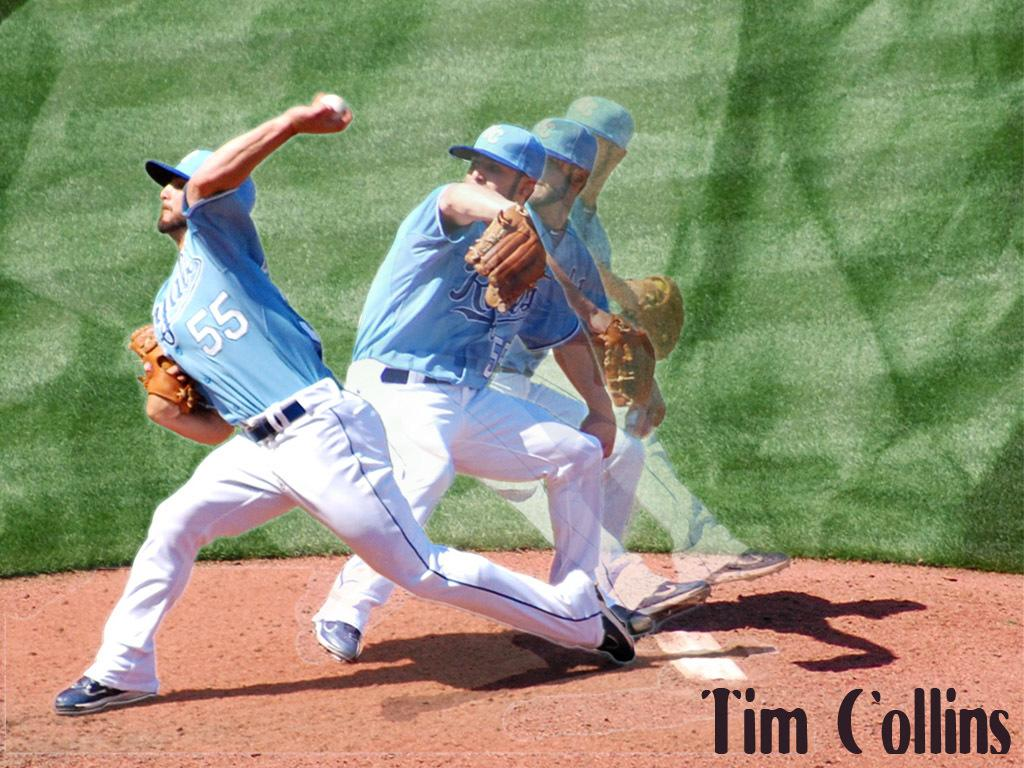<image>
Render a clear and concise summary of the photo. A baseball pitcher for the Royals is throwing a ball and the name Tim Collins is at the bottom of the image. 